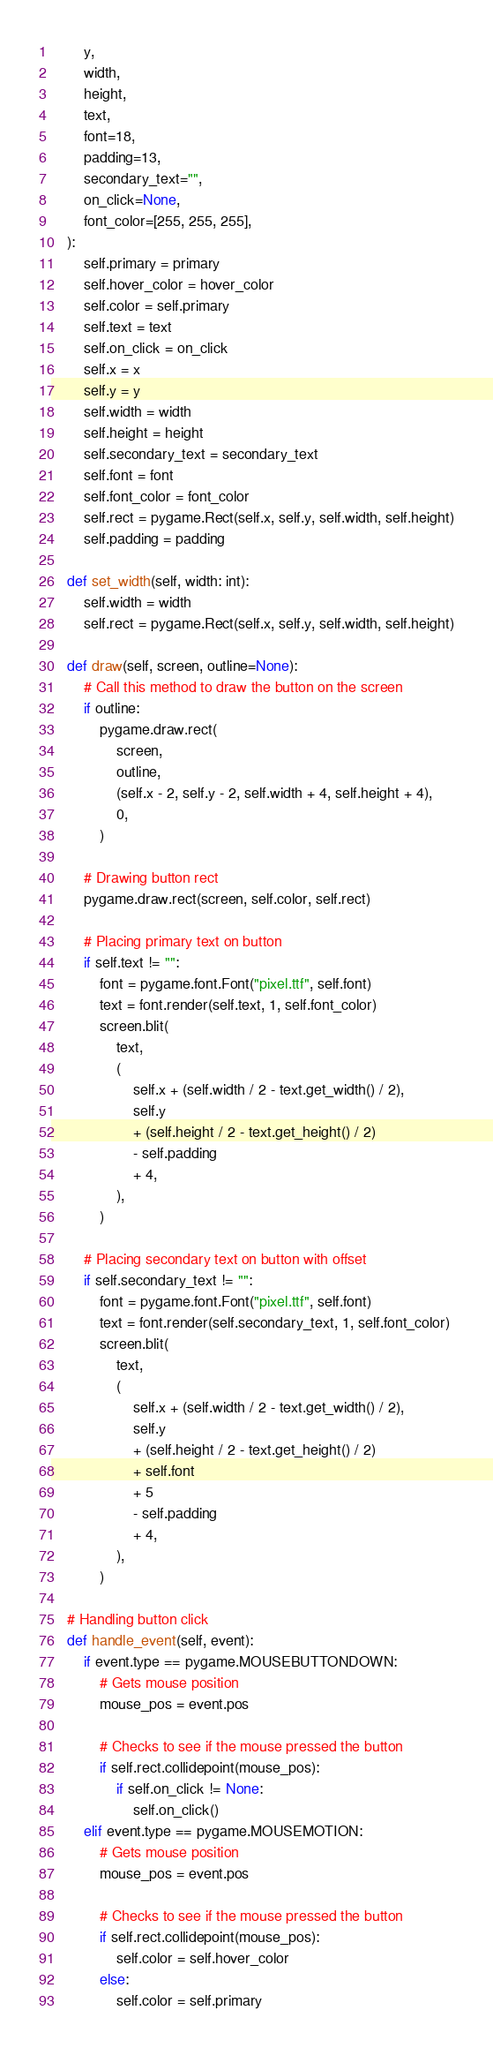Convert code to text. <code><loc_0><loc_0><loc_500><loc_500><_Python_>        y,
        width,
        height,
        text,
        font=18,
        padding=13,
        secondary_text="",
        on_click=None,
        font_color=[255, 255, 255],
    ):
        self.primary = primary
        self.hover_color = hover_color
        self.color = self.primary
        self.text = text
        self.on_click = on_click
        self.x = x
        self.y = y
        self.width = width
        self.height = height
        self.secondary_text = secondary_text
        self.font = font
        self.font_color = font_color
        self.rect = pygame.Rect(self.x, self.y, self.width, self.height)
        self.padding = padding

    def set_width(self, width: int):
        self.width = width
        self.rect = pygame.Rect(self.x, self.y, self.width, self.height)

    def draw(self, screen, outline=None):
        # Call this method to draw the button on the screen
        if outline:
            pygame.draw.rect(
                screen,
                outline,
                (self.x - 2, self.y - 2, self.width + 4, self.height + 4),
                0,
            )

        # Drawing button rect
        pygame.draw.rect(screen, self.color, self.rect)

        # Placing primary text on button
        if self.text != "":
            font = pygame.font.Font("pixel.ttf", self.font)
            text = font.render(self.text, 1, self.font_color)
            screen.blit(
                text,
                (
                    self.x + (self.width / 2 - text.get_width() / 2),
                    self.y
                    + (self.height / 2 - text.get_height() / 2)
                    - self.padding
                    + 4,
                ),
            )

        # Placing secondary text on button with offset
        if self.secondary_text != "":
            font = pygame.font.Font("pixel.ttf", self.font)
            text = font.render(self.secondary_text, 1, self.font_color)
            screen.blit(
                text,
                (
                    self.x + (self.width / 2 - text.get_width() / 2),
                    self.y
                    + (self.height / 2 - text.get_height() / 2)
                    + self.font
                    + 5
                    - self.padding
                    + 4,
                ),
            )

    # Handling button click
    def handle_event(self, event):
        if event.type == pygame.MOUSEBUTTONDOWN:
            # Gets mouse position
            mouse_pos = event.pos

            # Checks to see if the mouse pressed the button
            if self.rect.collidepoint(mouse_pos):
                if self.on_click != None:
                    self.on_click()
        elif event.type == pygame.MOUSEMOTION:
            # Gets mouse position
            mouse_pos = event.pos

            # Checks to see if the mouse pressed the button
            if self.rect.collidepoint(mouse_pos):
                self.color = self.hover_color
            else:
                self.color = self.primary
</code> 